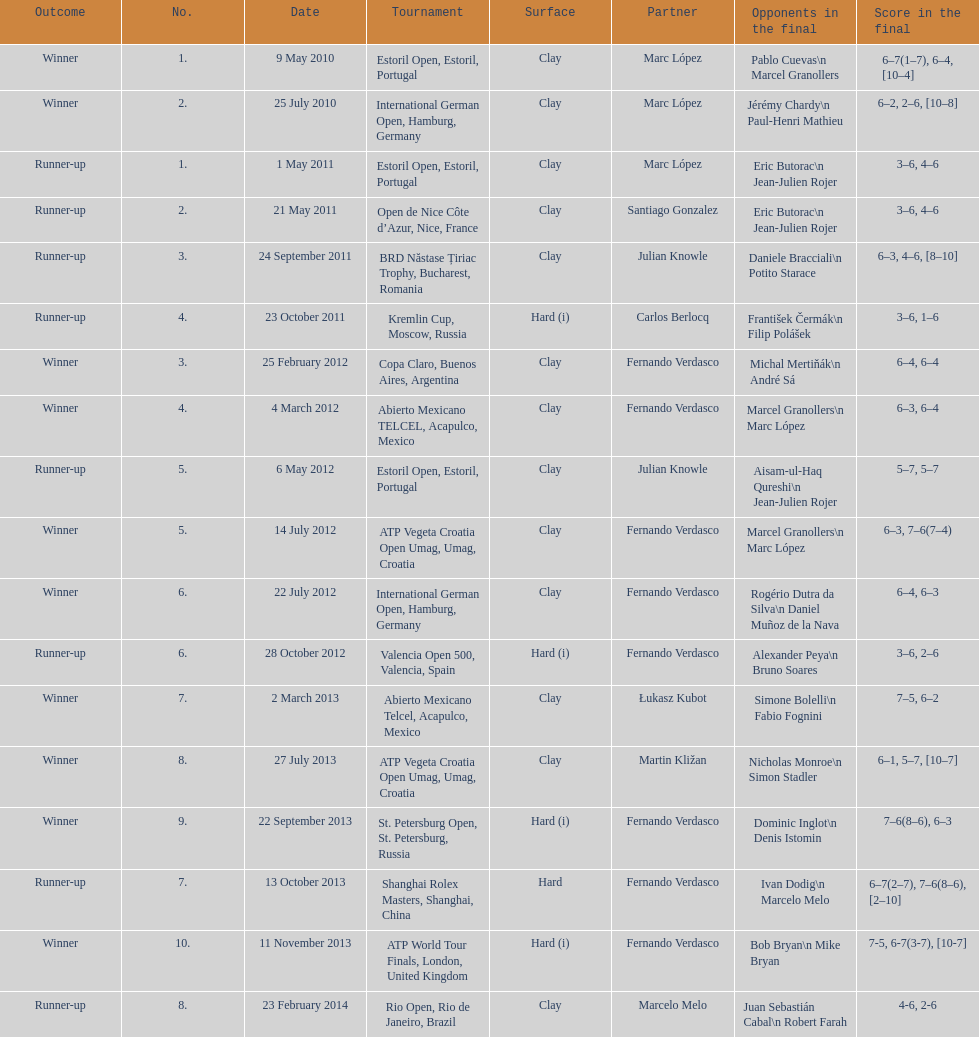What is the count of hard surface usage? 5. 